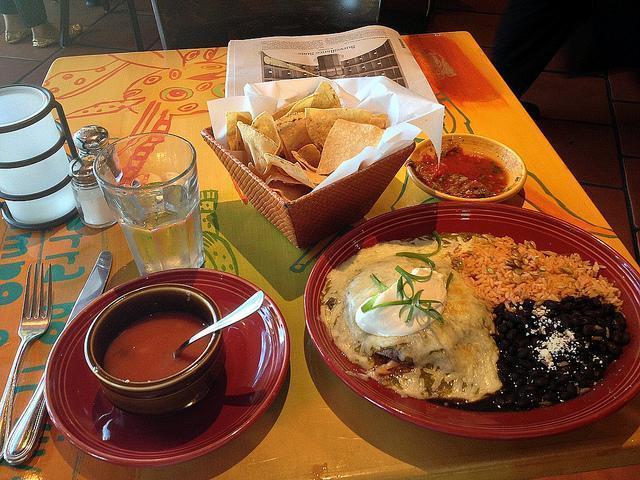How many dishes on the table?
Give a very brief answer. 2. How many bowls are in the photo?
Give a very brief answer. 3. How many zebra are in the water?
Give a very brief answer. 0. 